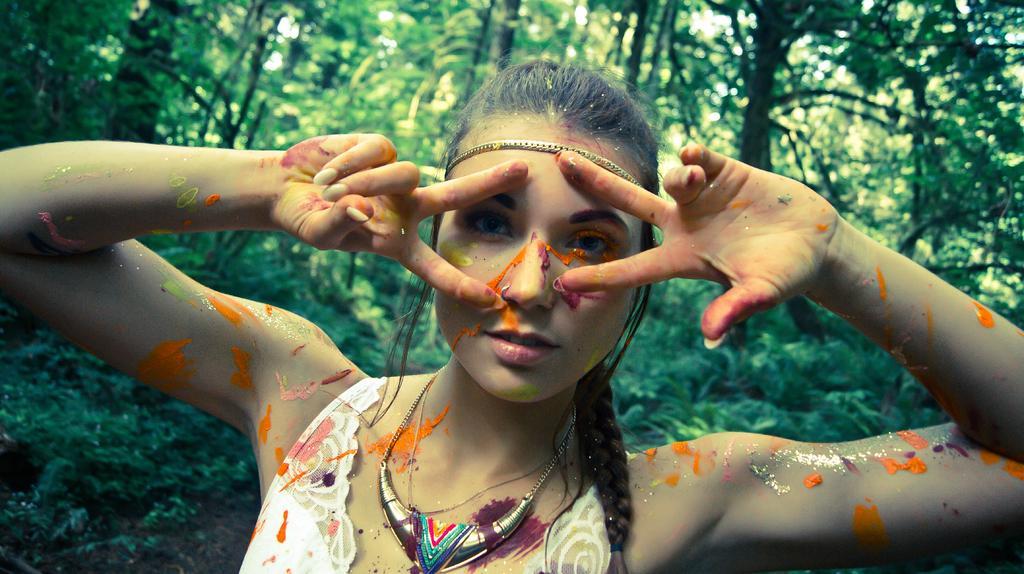Could you give a brief overview of what you see in this image? In this picture I can see a woman, in the background there are trees. 